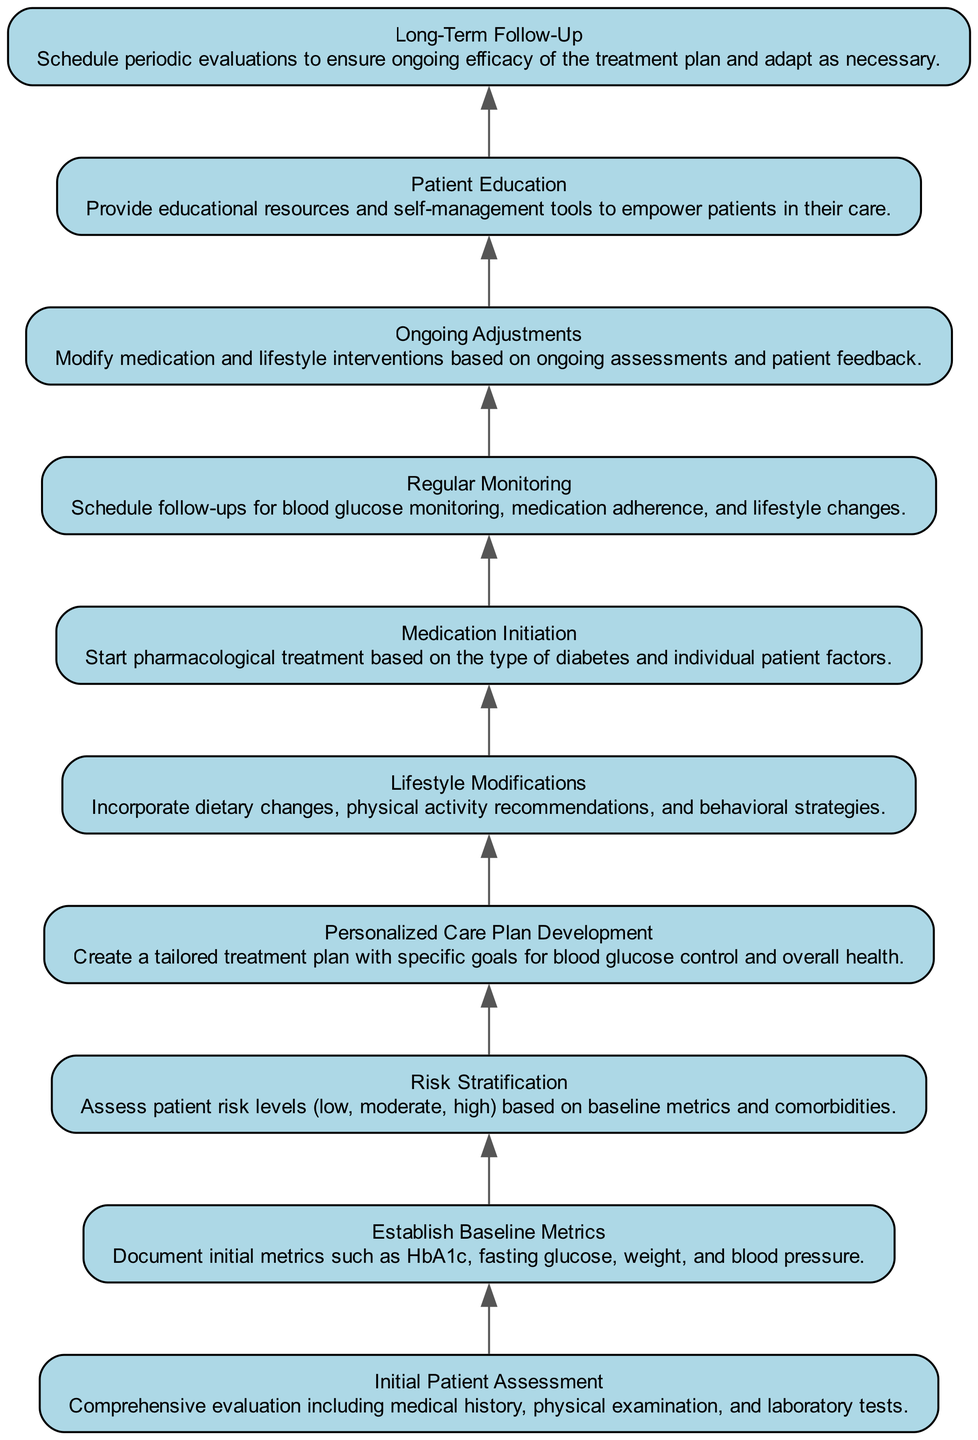What is the first step in the patient treatment pathway? The first step represented in the diagram is "Initial Patient Assessment." This step initializes the pathway for diabetes management.
Answer: Initial Patient Assessment How many steps are in the treatment pathway? Counting all the distinct elements in the diagram, there are ten steps from the initial assessment to long-term follow-up, as depicted.
Answer: 10 Which step follows personalized care plan development? After "Personalized Care Plan Development," the next step in the flow is "Lifestyle Modifications," as the arrows connecting the nodes point to this relationship.
Answer: Lifestyle Modifications What aspect is highlighted in the "Ongoing Adjustments" step? "Ongoing Adjustments" emphasizes modifying medication and lifestyle interventions based on assessments, indicating a dynamic aspect of diabetes management that responds to patient feedback.
Answer: Modify medication and lifestyle interventions Which steps involve patient education? The "Patient Education" step specifically focuses on providing resources and self-management tools to empower patients, which directly connects to their active involvement in their healthcare.
Answer: Patient Education Describe the relationship between "Risk Stratification" and "Medication Initiation." "Risk Stratification" analyzes patient risk based on metrics and comorbidities, which informs the decisions made in "Medication Initiation," indicating a dependency where medication choices are influenced by assessed risks.
Answer: Medication choices are influenced by assessed risks What is the final step in the patient treatment pathway? The last step depicted in the flow diagram is "Long-Term Follow-Up." This reflects the importance of ongoing evaluation after initial treatment.
Answer: Long-Term Follow-Up Which steps involve follow-up activities? "Regular Monitoring" and "Long-Term Follow-Up" both involve follow-up activities to ensure treatment efficacy, with the former focusing on immediate assessments and the latter on periodic evaluations.
Answer: Regular Monitoring and Long-Term Follow-Up What is the significance of the "Regular Monitoring" step? "Regular Monitoring" is crucial as it concerns scheduling follow-ups for monitoring blood glucose levels, medication adherence, and lifestyle changes, ensuring the patient’s treatment remains effective.
Answer: Ensuring effective treatment What type of diabetes treatment is initiated in the "Medication Initiation" step? This step begins pharmacological treatment specifically tailored to the patient's type of diabetes and individual factors, establishing the foundation for medical management of their condition.
Answer: Pharmacological treatment 